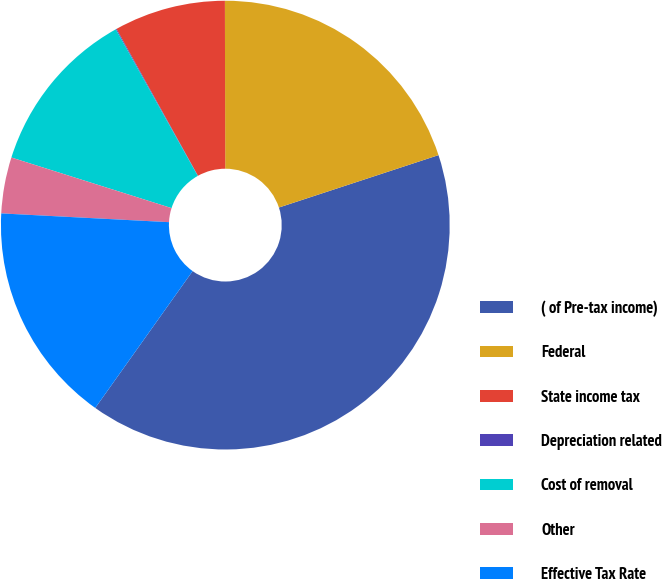Convert chart to OTSL. <chart><loc_0><loc_0><loc_500><loc_500><pie_chart><fcel>( of Pre-tax income)<fcel>Federal<fcel>State income tax<fcel>Depreciation related<fcel>Cost of removal<fcel>Other<fcel>Effective Tax Rate<nl><fcel>39.89%<fcel>19.98%<fcel>8.03%<fcel>0.06%<fcel>12.01%<fcel>4.04%<fcel>15.99%<nl></chart> 